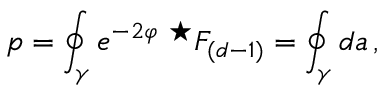<formula> <loc_0><loc_0><loc_500><loc_500>p = \oint _ { \gamma } e ^ { - 2 \varphi } ^ { ^ { * } } F _ { ( d - 1 ) } = \oint _ { \gamma } d a \, ,</formula> 